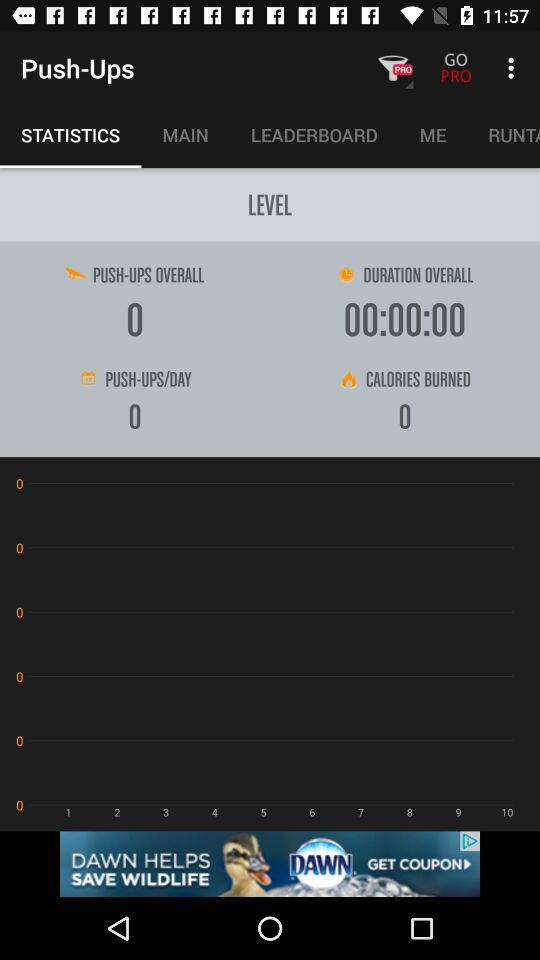Which option is selected? The selected option is "STATISTICS". 